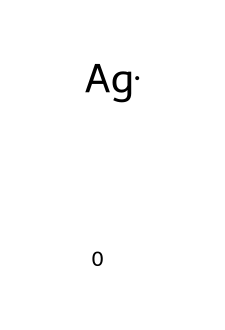What is the elemental composition of the conductive ink? The SMILES representation shows only silver (Ag) as the element present, indicating that the conductive ink is composed entirely of silver.
Answer: silver How many atoms are present in this chemical structure? The SMILES notation contains a single element symbol (Ag), representing one atom of silver in the structure.
Answer: 1 What is the oxidation state of silver in this chemical? In most conductive inks, silver typically exhibits an oxidation state of zero, as it is represented as a pure element in the SMILES notation.
Answer: 0 What type of bond is primarily involved in this conductive ink? The SMILES representation indicates that it is composed of elemental silver, which doesn't involve any specific types of bonds like covalent or ionic in the traditional sense; instead, it is primarily metallic bonds that are present in silver.
Answer: metallic Which physical property is enhanced by the use of silver in conductive ink? Silver is known for its excellent electrical conductivity; thus, its inclusion in conductive ink significantly enhances this property, allowing for effective current flow in printed circuits.
Answer: electrical conductivity What is the role of silver in printed circuit board applications? Silver serves as a conductive agent in printed circuit boards, providing pathways for electrical signals due to its high conductivity and ability to form conductive inks.
Answer: conductive agent Why is silver used instead of another metal in conductive ink? Silver is preferred due to its superior electrical conductivity, better than other metals like copper or aluminum, and its resistance to oxidation, making it ideal for long-term use in electronic applications.
Answer: superior conductivity 